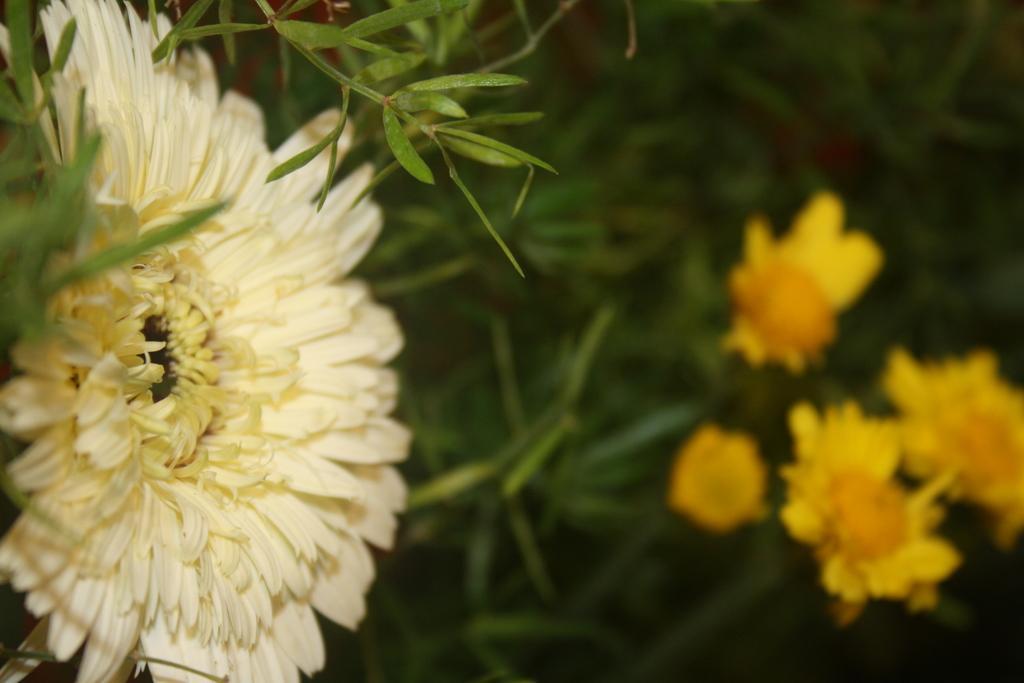Can you describe this image briefly? In this image there are flowers and there are leaves. 